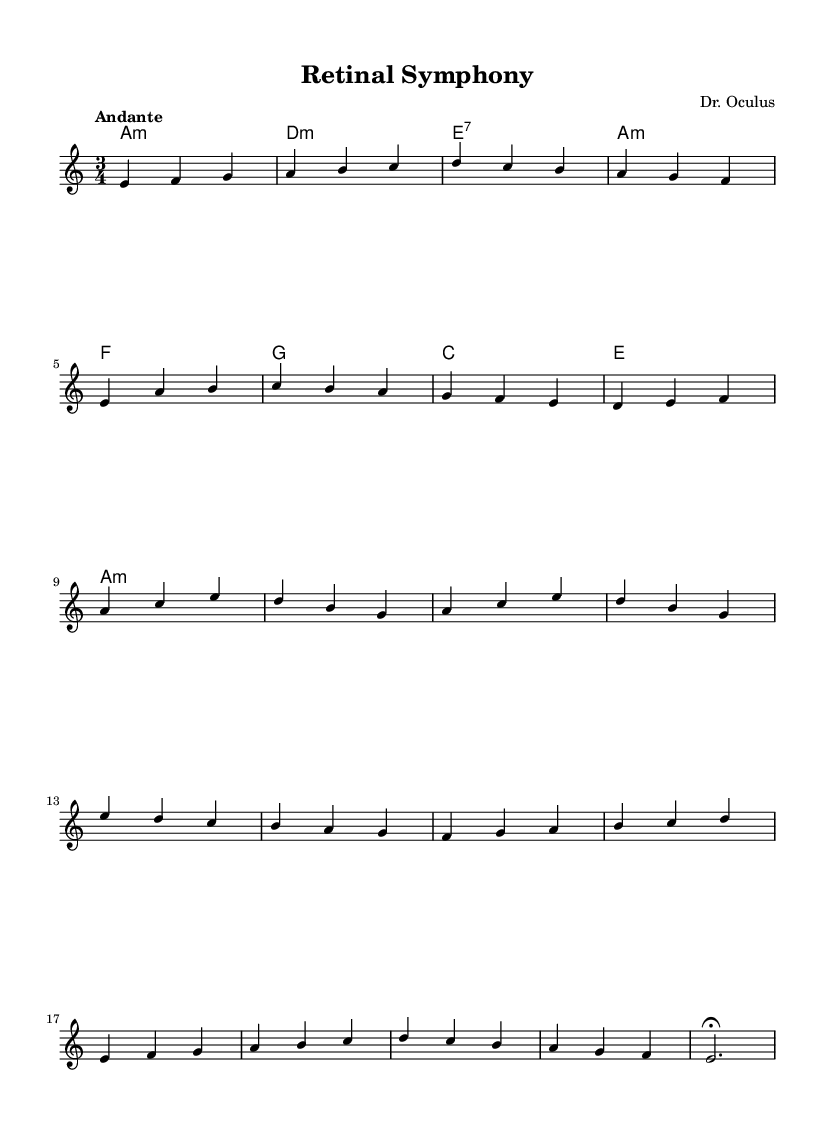What is the title of this piece? The title is indicated in the header section of the sheet music as "Retinal Symphony."
Answer: Retinal Symphony What is the key signature of this music? The key signature is indicated at the beginning of the score where it shows A minor, which has no sharps or flats.
Answer: A minor What is the time signature of this piece? The time signature is indicated next to the key signature at the beginning of the score, which shows a 3/4 time signature.
Answer: 3/4 What is the tempo marking for this piece? The tempo marking is noted in the global context of the sheet music as "Andante," which indicates a moderately slow tempo.
Answer: Andante How many sections are present in the piece? Analyzing the structure, the piece is divided into four sections: Intro, A, B, C, and an Outro, totaling five distinct parts.
Answer: Five Which harmonic chord appears first in the piece? The first chord indicated in the harmonies section is A minor, as it appears at the beginning of the harmonic progression.
Answer: A minor What is the final note of the piece? The final note is indicated in the Outro, and it is an E note, marked with a fermata, suggesting to hold it longer.
Answer: E 